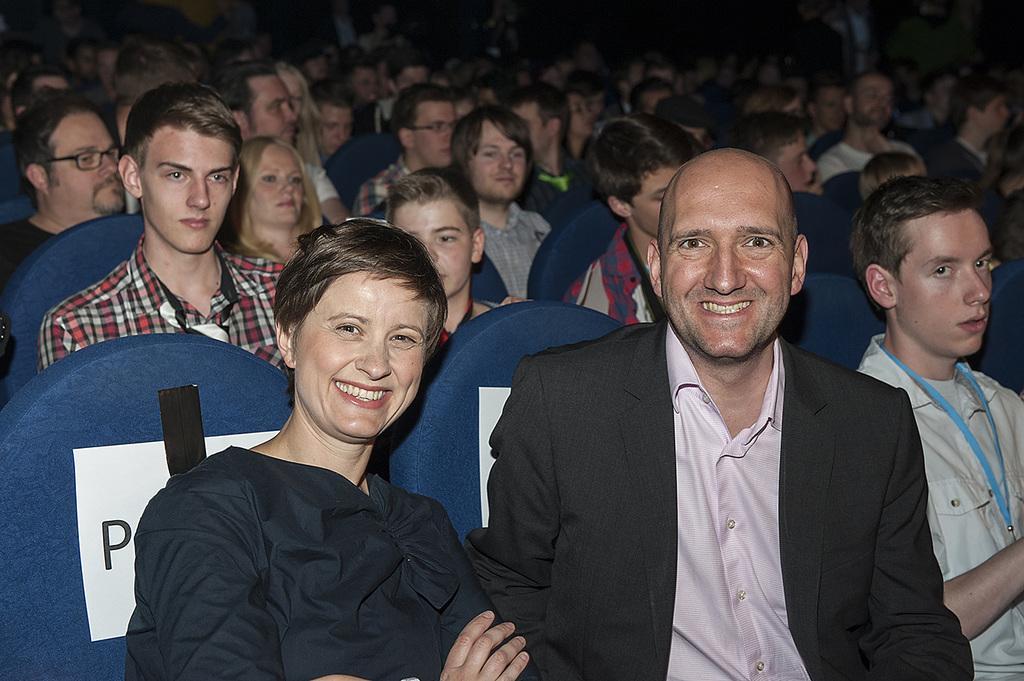Please provide a concise description of this image. There are few persons sitting in blue chair. 